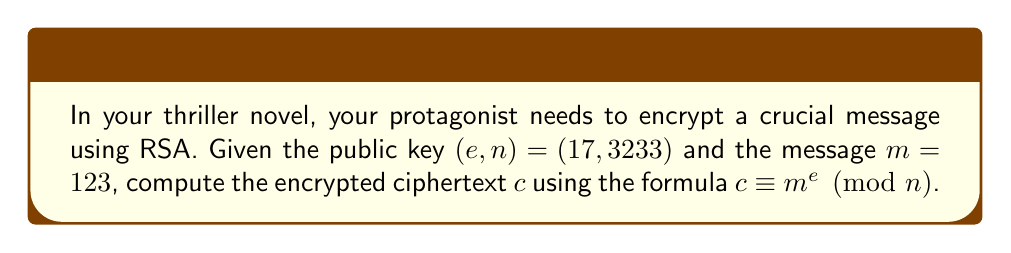Could you help me with this problem? To compute the modular exponentiation for RSA encryption, we need to follow these steps:

1) We have:
   $m = 123$ (the message)
   $e = 17$ (the public exponent)
   $n = 3233$ (the modulus)

2) We need to calculate $c \equiv 123^{17} \pmod{3233}$

3) Direct computation of $123^{17}$ would result in a very large number. Instead, we can use the square-and-multiply algorithm:

   $123^{17} = 123^{(10001)_2}$ (17 in binary is 10001)

4) Start with $x = 123$:
   
   $x \equiv 123 \pmod{3233}$

5) Square (corresponding to the first '1' in binary):
   
   $x \equiv 123^2 \pmod{3233} \equiv 15129 \pmod{3233} \equiv 2197 \pmod{3233}$

6) Square three more times (corresponding to the '000' in binary):
   
   $x \equiv 2197^2 \pmod{3233} \equiv 1864 \pmod{3233}$
   $x \equiv 1864^2 \pmod{3233} \equiv 2071 \pmod{3233}$
   $x \equiv 2071^2 \pmod{3233} \equiv 799 \pmod{3233}$

7) Multiply by the original value (corresponding to the last '1' in binary):
   
   $x \equiv (799 \cdot 123) \pmod{3233} \equiv 98277 \pmod{3233} \equiv 855 \pmod{3233}$

Therefore, the encrypted ciphertext $c$ is 855.
Answer: $855$ 